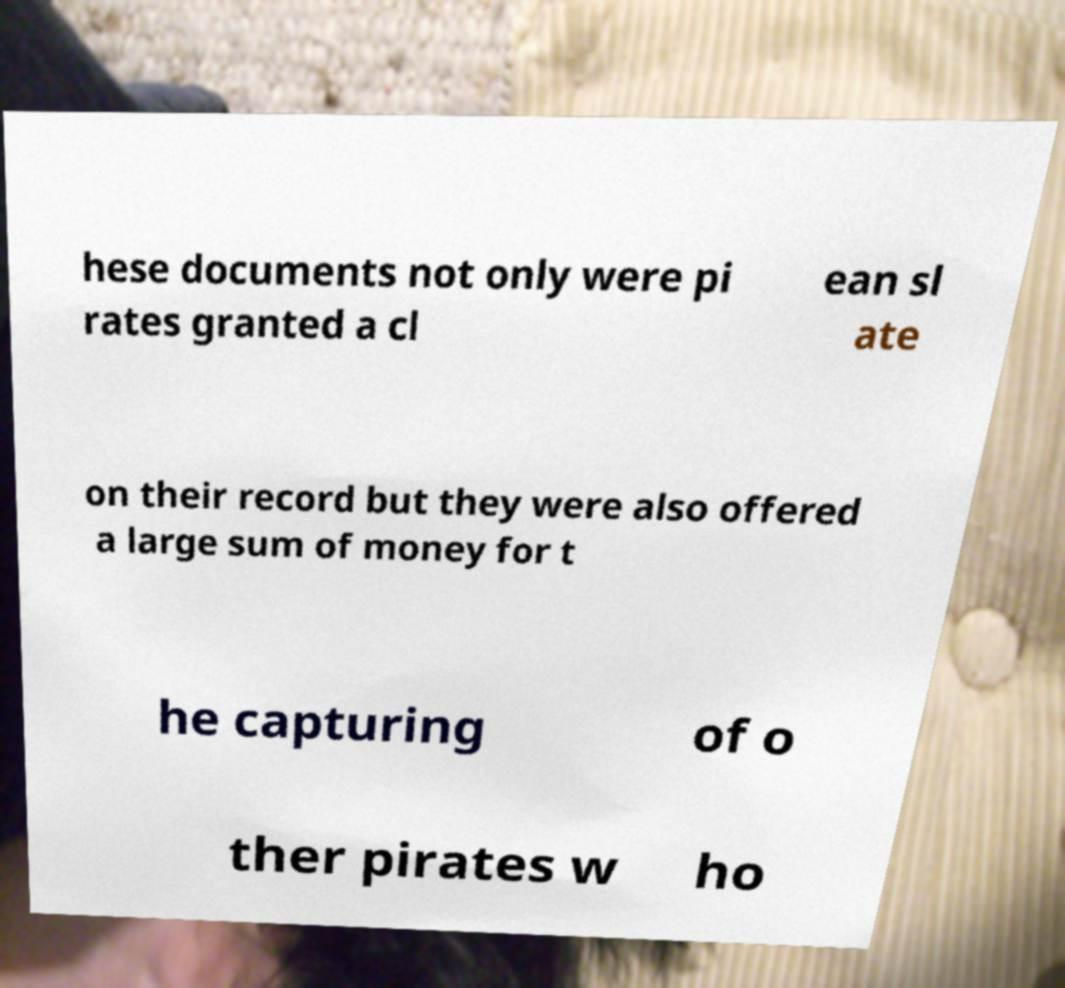Please identify and transcribe the text found in this image. hese documents not only were pi rates granted a cl ean sl ate on their record but they were also offered a large sum of money for t he capturing of o ther pirates w ho 